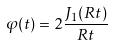Convert formula to latex. <formula><loc_0><loc_0><loc_500><loc_500>\varphi ( t ) = 2 \frac { J _ { 1 } ( R t ) } { R t }</formula> 